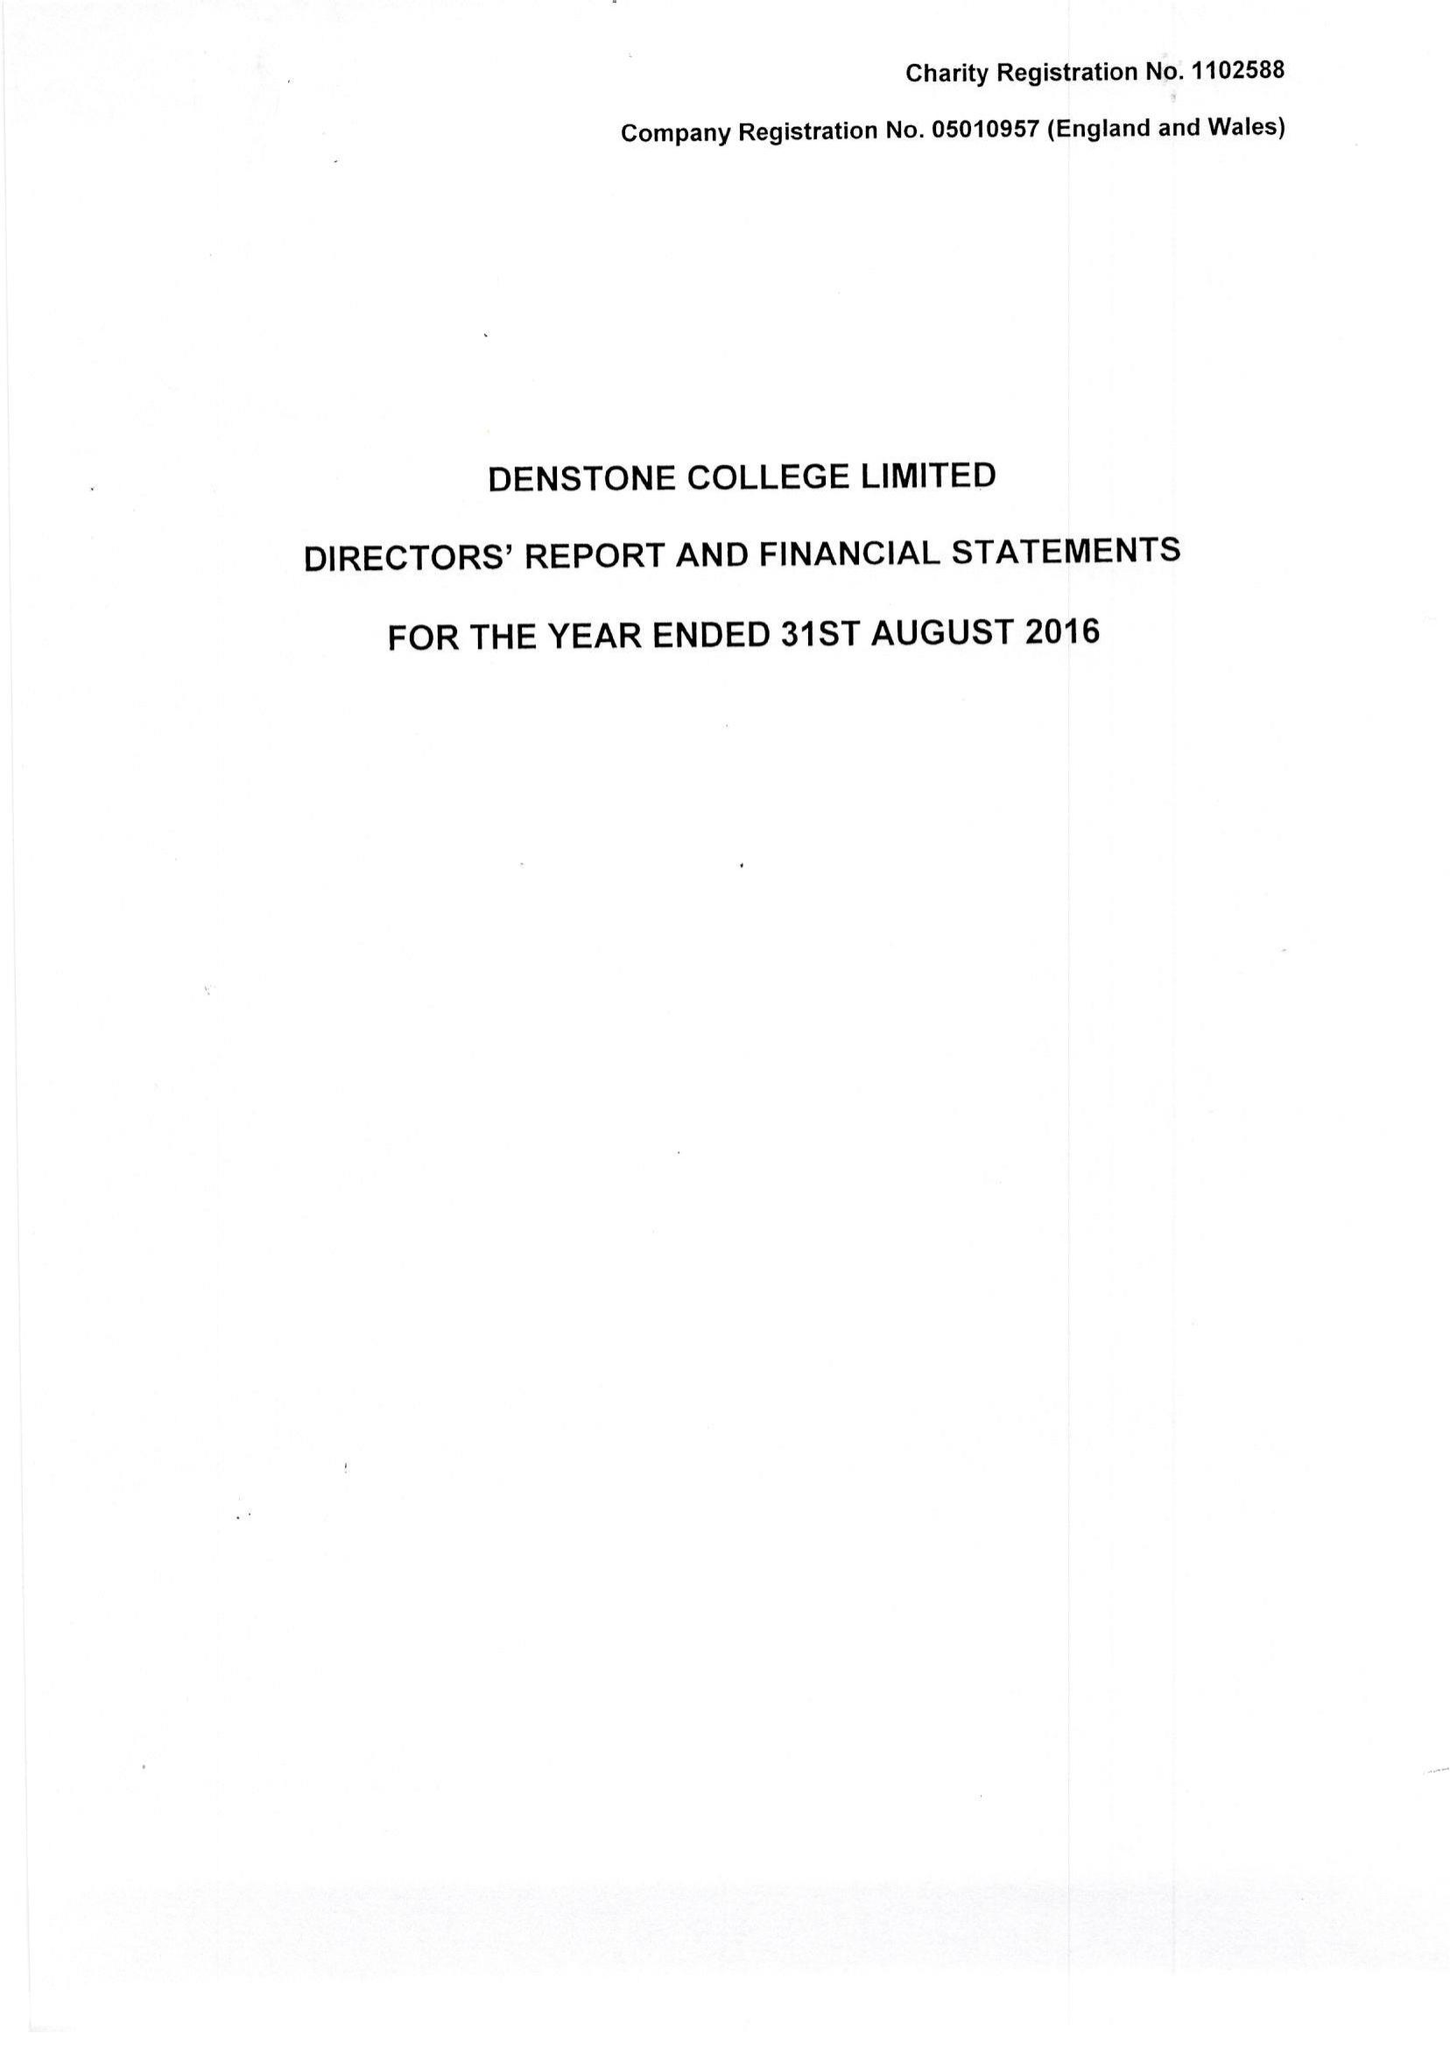What is the value for the charity_number?
Answer the question using a single word or phrase. 1102588 